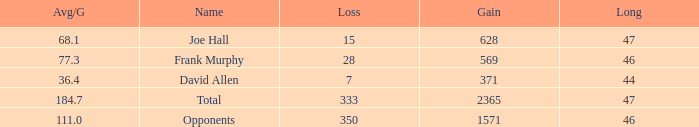How much Avg/G has a Gain smaller than 1571, and a Long smaller than 46? 1.0. 